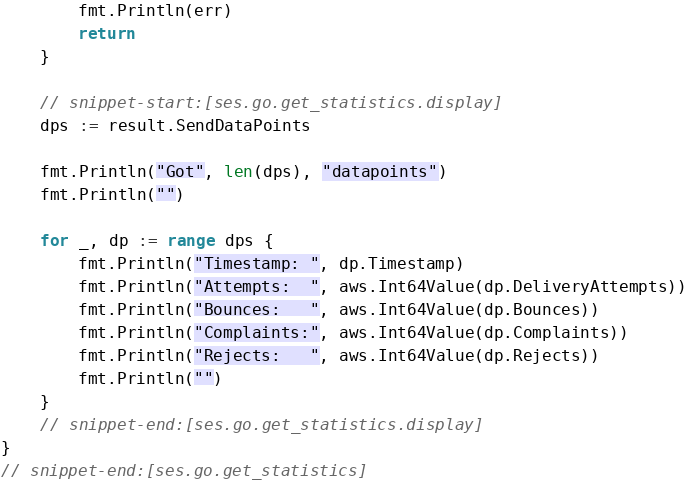<code> <loc_0><loc_0><loc_500><loc_500><_Go_>        fmt.Println(err)
        return
    }

    // snippet-start:[ses.go.get_statistics.display]
    dps := result.SendDataPoints

    fmt.Println("Got", len(dps), "datapoints")
    fmt.Println("")

    for _, dp := range dps {
        fmt.Println("Timestamp: ", dp.Timestamp)
        fmt.Println("Attempts:  ", aws.Int64Value(dp.DeliveryAttempts))
        fmt.Println("Bounces:   ", aws.Int64Value(dp.Bounces))
        fmt.Println("Complaints:", aws.Int64Value(dp.Complaints))
        fmt.Println("Rejects:   ", aws.Int64Value(dp.Rejects))
        fmt.Println("")
    }
    // snippet-end:[ses.go.get_statistics.display]
}
// snippet-end:[ses.go.get_statistics]
</code> 